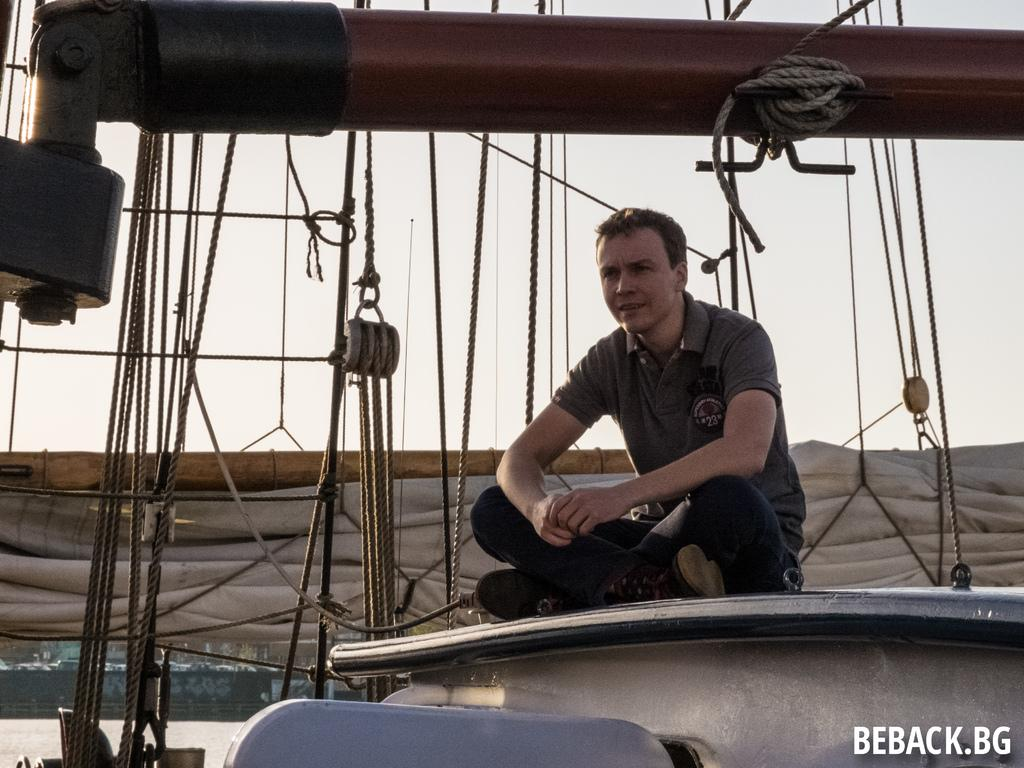What is the man in the image doing? The man is sitting in the image. What can be seen in the background of the image? There are ropes visible in the background of the image. Is there any text or marking in the image? Yes, there is a watermark in the right bottom corner of the image. What type of badge is the man wearing in the middle of the image? There is no badge visible in the image, and the man is sitting on the left side, not in the middle. 